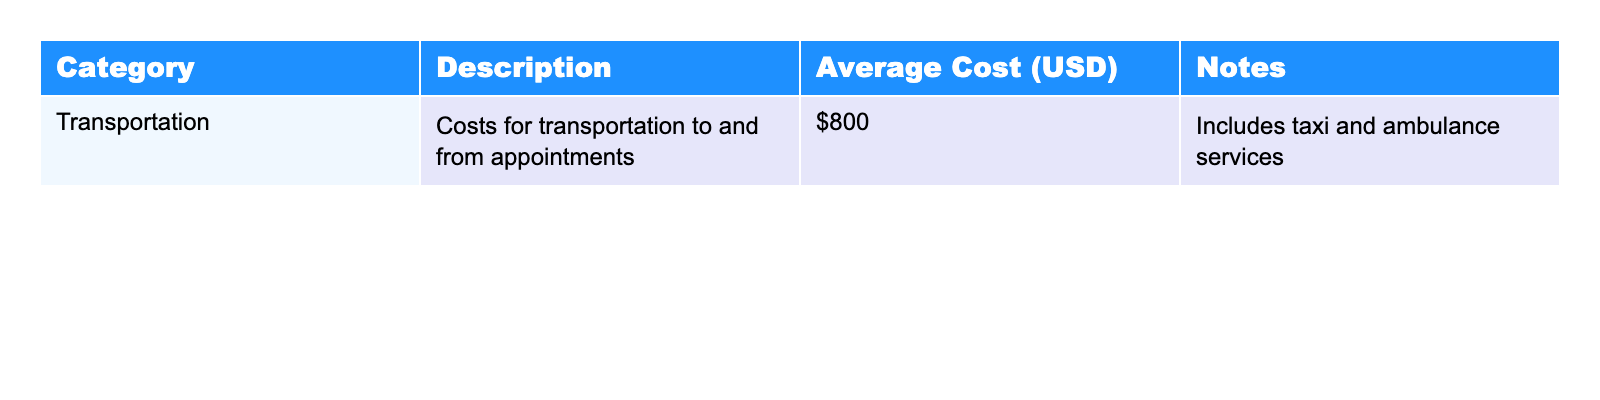What is the average cost of transportation? The table lists the average cost for transportation as $800.
Answer: $800 Does the table include information about other categories of expenses? The table only includes transportation as a category and does not provide details on other categories.
Answer: No Is the average cost for transportation higher or lower than $1000? The average cost of $800 is lower than $1000.
Answer: Lower What total would you get if you combined the average transportation costs from two patients? Since the average cost for one patient is $800, combining for two patients gives $800 + $800 = $1600.
Answer: $1600 What type of services are included in the transportation costs? The table states that transportation costs include taxi and ambulance services.
Answer: Taxi and ambulance services If someone spends $1,500 on transportation, how much more is that than the average cost listed in the table? Subtract the average cost of transportation ($800) from $1,500: $1,500 - $800 = $700.
Answer: $700 Assuming transportation costs are the only expenses one might encounter, what would be the average expense for three patients? If each patient spends an average of $800, the total for three patients is $800 * 3 = $2400, and the average remains $800.
Answer: $800 Are there any notes provided for the transportation costs in the table? Yes, the notes indicate that the costs include taxi and ambulance services.
Answer: Yes If transportation costs increase by 25%, what would the new average cost be? Calculate 25% of $800, which is $200, and add it to $800: $800 + $200 = $1000.
Answer: $1000 Can you conclude that transportation costs are manageable based on the average figure provided? The $800 average cost may be manageable for some, but it could be high for others depending on their financial situation.
Answer: Cannot conclude without more context 